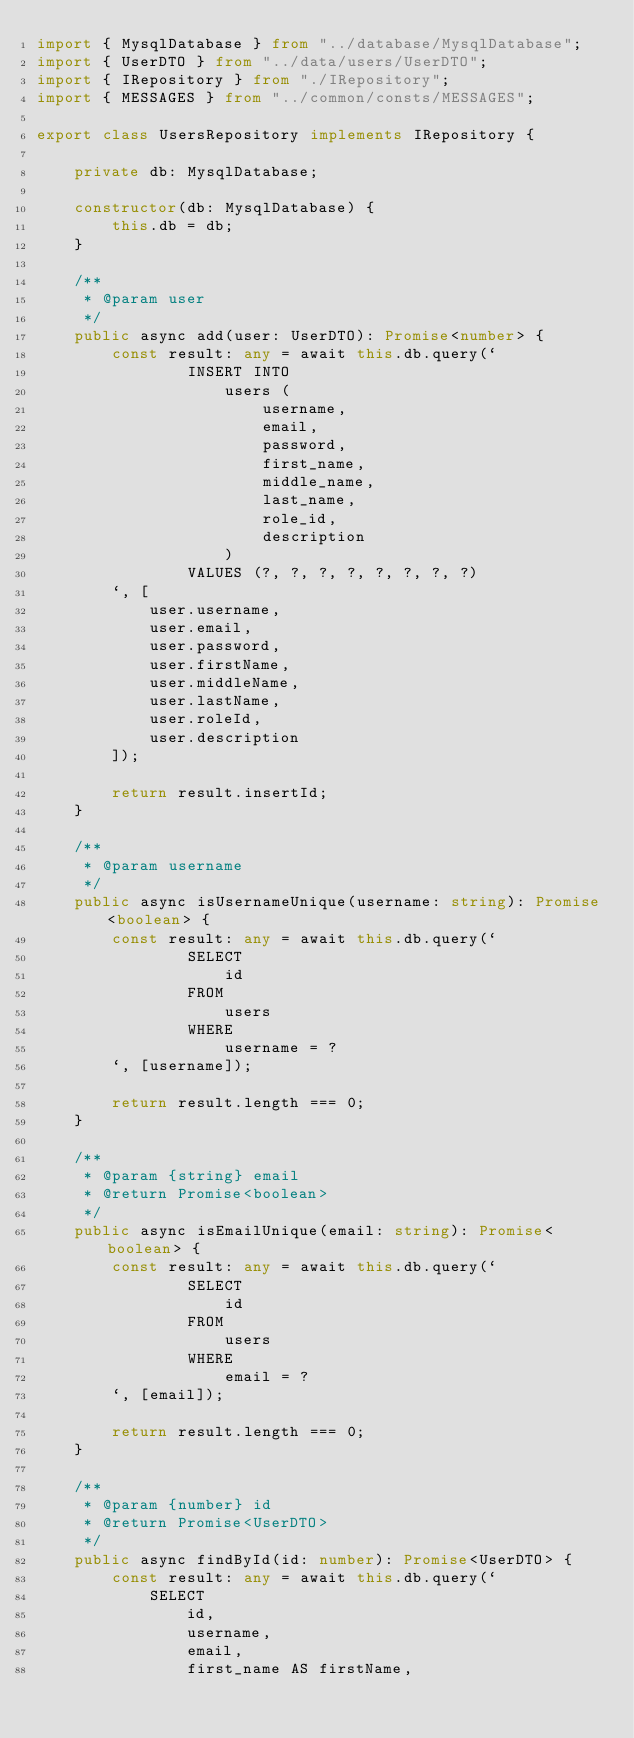Convert code to text. <code><loc_0><loc_0><loc_500><loc_500><_TypeScript_>import { MysqlDatabase } from "../database/MysqlDatabase";
import { UserDTO } from "../data/users/UserDTO";
import { IRepository } from "./IRepository";
import { MESSAGES } from "../common/consts/MESSAGES";

export class UsersRepository implements IRepository {

    private db: MysqlDatabase;

    constructor(db: MysqlDatabase) {
        this.db = db;
    }

    /**
     * @param user
     */
    public async add(user: UserDTO): Promise<number> {
        const result: any = await this.db.query(`
                INSERT INTO
                    users (
                        username,
                        email,
                        password,
                        first_name,
                        middle_name,
                        last_name,
                        role_id,
                        description
                    )
                VALUES (?, ?, ?, ?, ?, ?, ?, ?)
        `, [
            user.username,
            user.email,
            user.password,
            user.firstName,
            user.middleName,
            user.lastName,
            user.roleId,
            user.description
        ]);

        return result.insertId;
    }

    /**
     * @param username
     */
    public async isUsernameUnique(username: string): Promise<boolean> {
        const result: any = await this.db.query(`
                SELECT
                    id
                FROM
                    users
                WHERE
                    username = ?
        `, [username]);

        return result.length === 0;
    }

    /**
     * @param {string} email
     * @return Promise<boolean>
     */
    public async isEmailUnique(email: string): Promise<boolean> {
        const result: any = await this.db.query(`
                SELECT
                    id
                FROM
                    users
                WHERE
                    email = ?
        `, [email]);

        return result.length === 0;
    }

    /**
     * @param {number} id
     * @return Promise<UserDTO>
     */
    public async findById(id: number): Promise<UserDTO> {
        const result: any = await this.db.query(`
            SELECT
                id,
                username,
                email,
                first_name AS firstName,</code> 